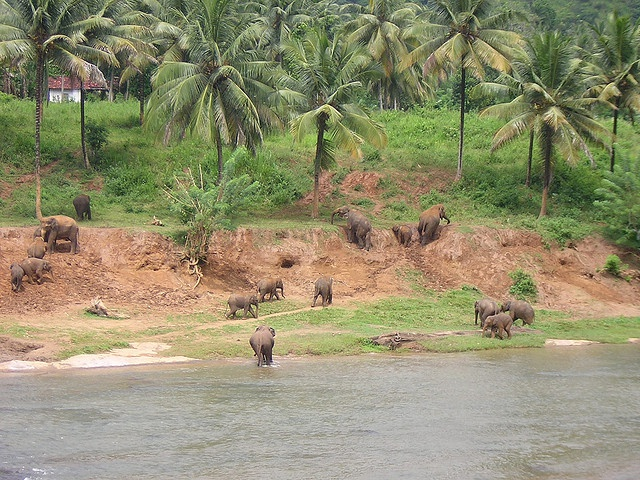Describe the objects in this image and their specific colors. I can see elephant in olive, gray, maroon, and tan tones, elephant in olive, gray, and maroon tones, elephant in olive, tan, gray, and darkgray tones, elephant in olive, gray, tan, and maroon tones, and elephant in olive, gray, and tan tones in this image. 